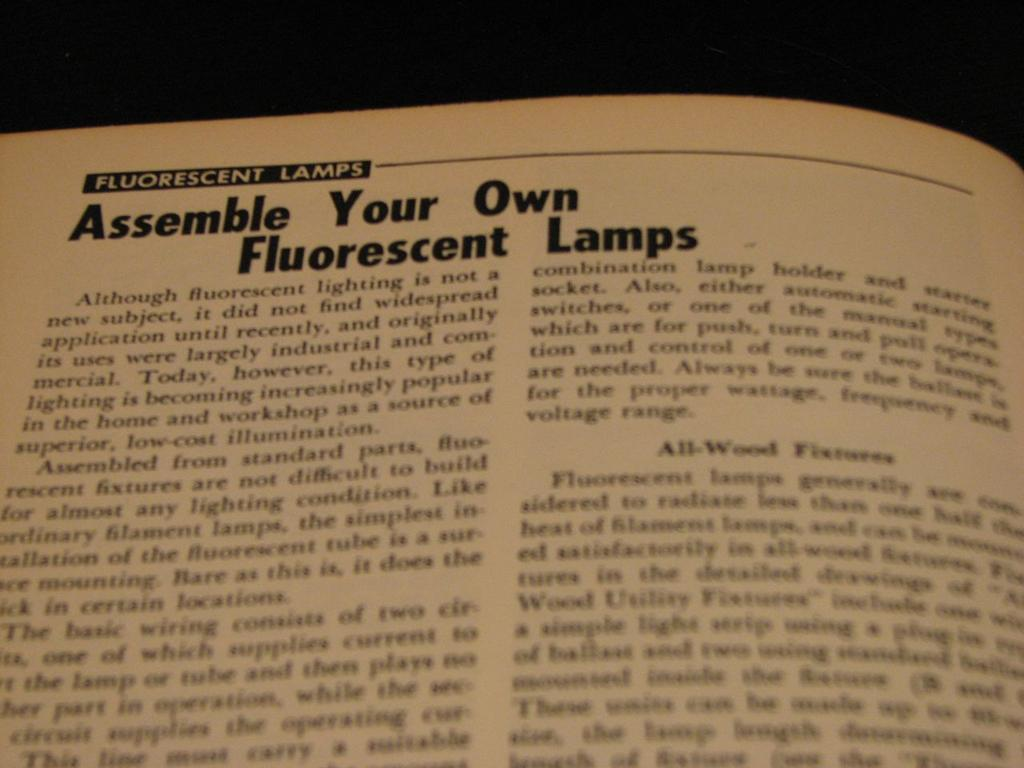<image>
Present a compact description of the photo's key features. A portion of a book page giving information about assembling Fluorescent lamps. 